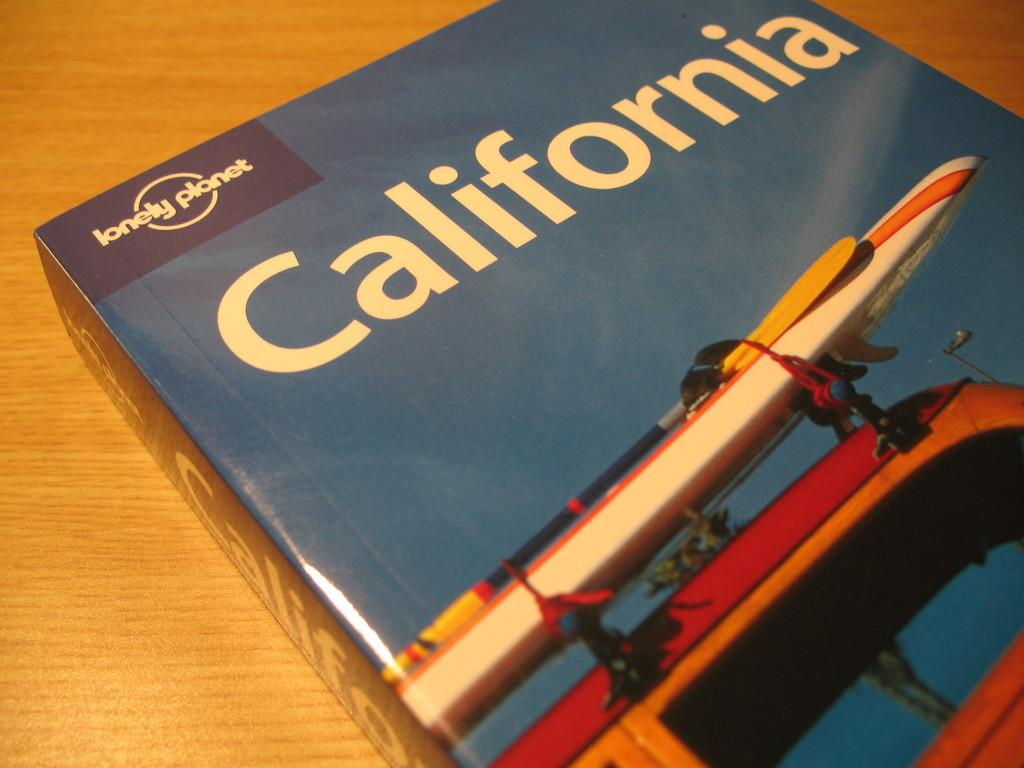Provide a one-sentence caption for the provided image. A book, entitled California, lays on a table. 